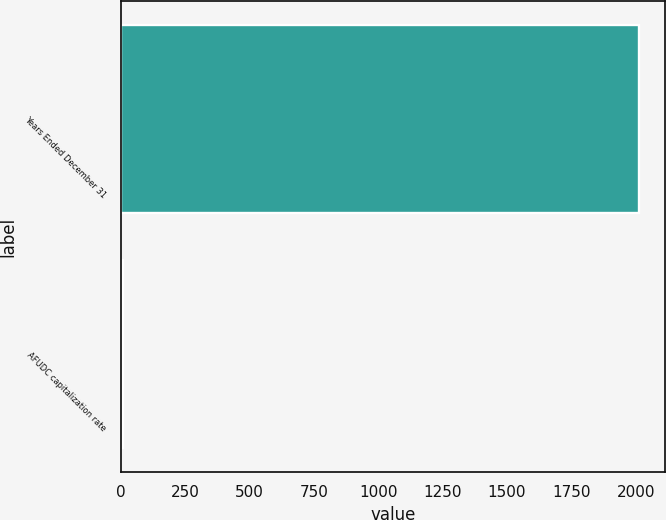<chart> <loc_0><loc_0><loc_500><loc_500><bar_chart><fcel>Years Ended December 31<fcel>AFUDC capitalization rate<nl><fcel>2012<fcel>7.3<nl></chart> 